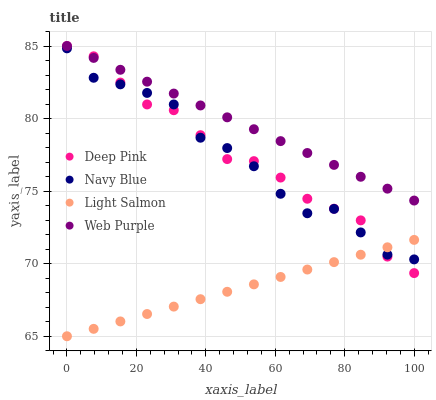Does Light Salmon have the minimum area under the curve?
Answer yes or no. Yes. Does Web Purple have the maximum area under the curve?
Answer yes or no. Yes. Does Deep Pink have the minimum area under the curve?
Answer yes or no. No. Does Deep Pink have the maximum area under the curve?
Answer yes or no. No. Is Web Purple the smoothest?
Answer yes or no. Yes. Is Navy Blue the roughest?
Answer yes or no. Yes. Is Light Salmon the smoothest?
Answer yes or no. No. Is Light Salmon the roughest?
Answer yes or no. No. Does Light Salmon have the lowest value?
Answer yes or no. Yes. Does Deep Pink have the lowest value?
Answer yes or no. No. Does Web Purple have the highest value?
Answer yes or no. Yes. Does Light Salmon have the highest value?
Answer yes or no. No. Is Light Salmon less than Web Purple?
Answer yes or no. Yes. Is Web Purple greater than Light Salmon?
Answer yes or no. Yes. Does Deep Pink intersect Web Purple?
Answer yes or no. Yes. Is Deep Pink less than Web Purple?
Answer yes or no. No. Is Deep Pink greater than Web Purple?
Answer yes or no. No. Does Light Salmon intersect Web Purple?
Answer yes or no. No. 